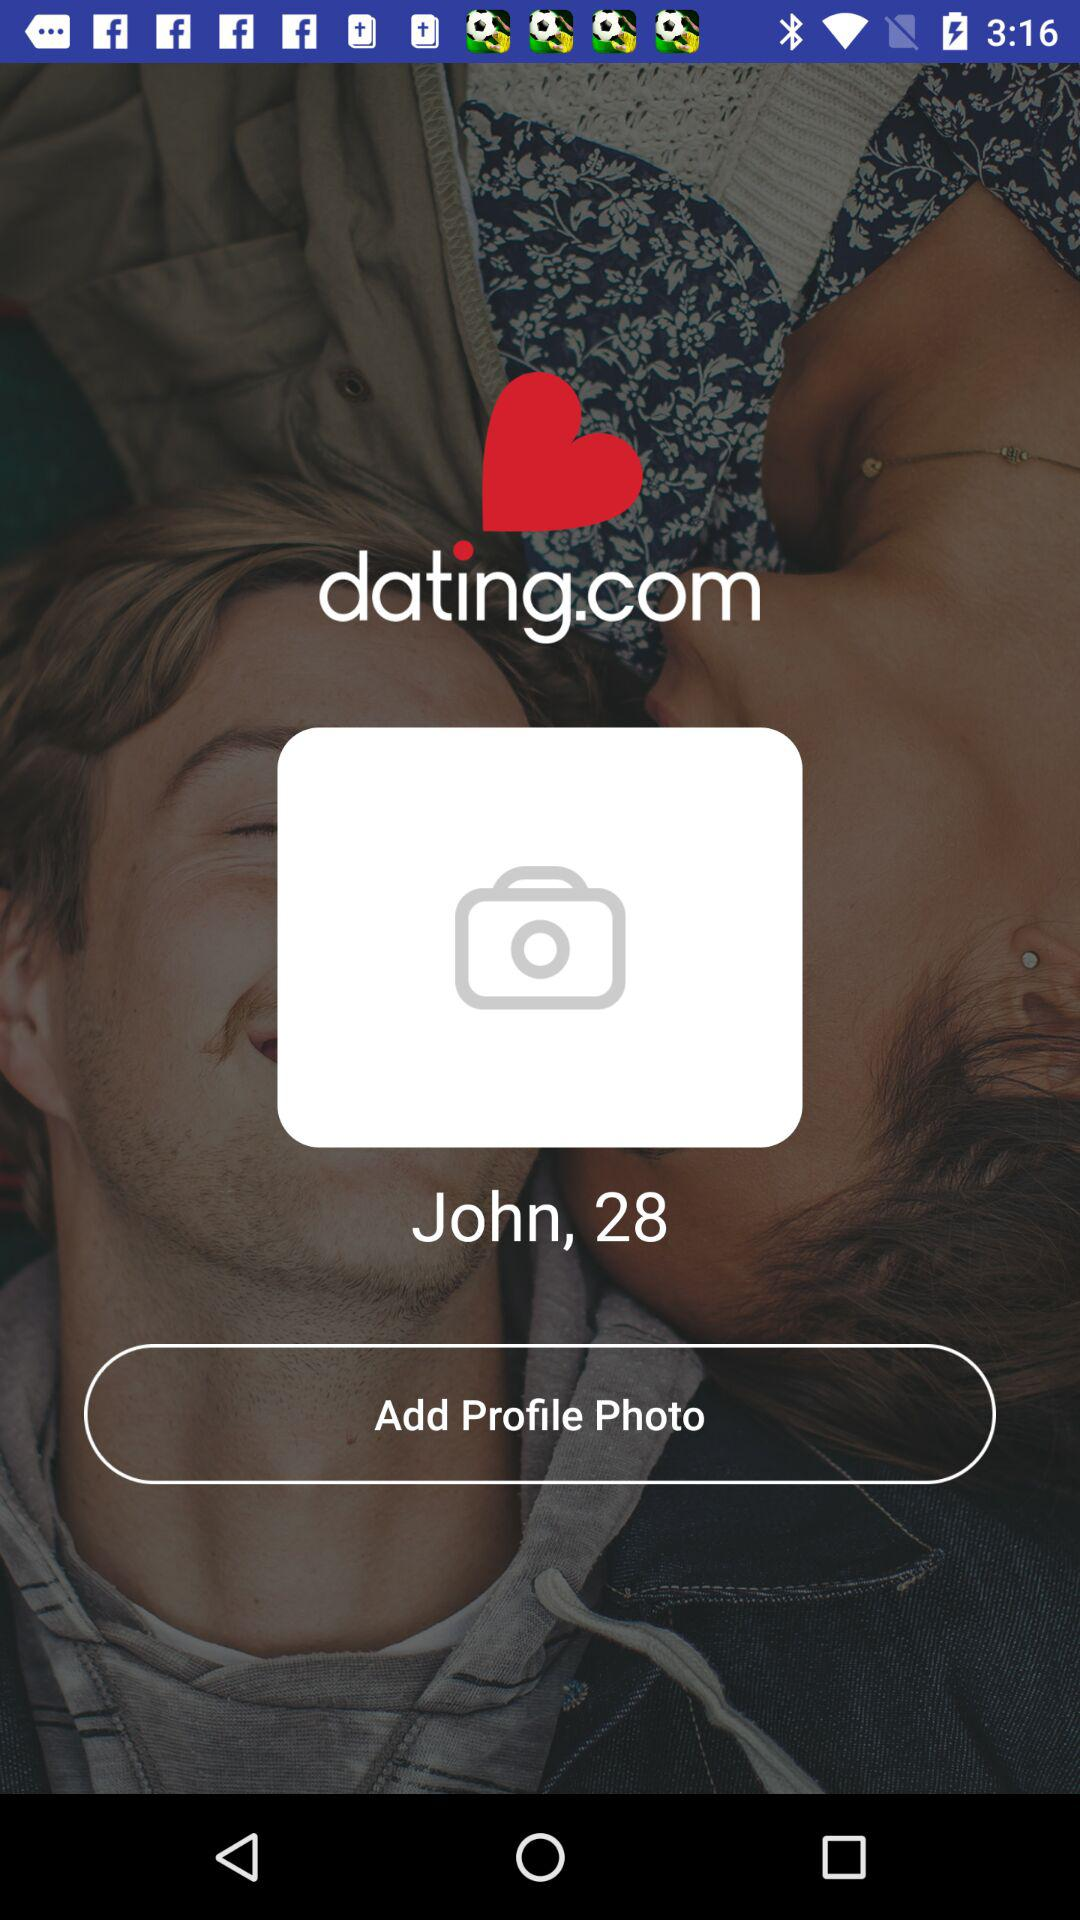What is the app name? The app name is "dating.com". 